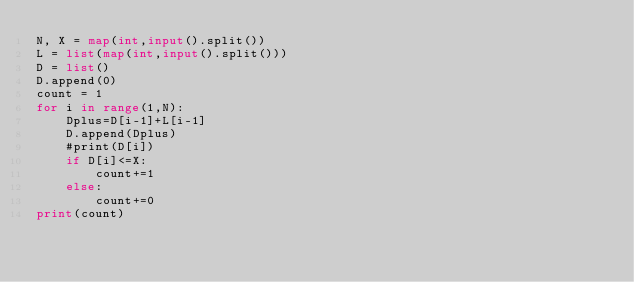Convert code to text. <code><loc_0><loc_0><loc_500><loc_500><_Python_>N, X = map(int,input().split())
L = list(map(int,input().split()))
D = list()
D.append(0)
count = 1
for i in range(1,N):
    Dplus=D[i-1]+L[i-1]
    D.append(Dplus)
    #print(D[i])
    if D[i]<=X:
        count+=1
    else:
        count+=0
print(count)</code> 